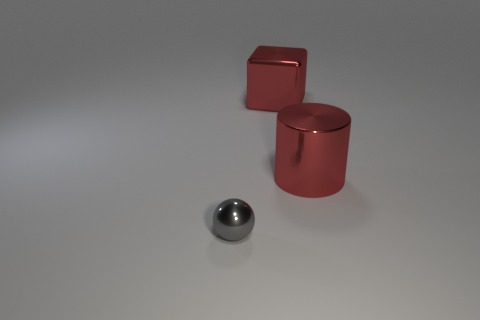Add 1 tiny gray rubber objects. How many objects exist? 4 Subtract all cylinders. How many objects are left? 2 Subtract 1 red cylinders. How many objects are left? 2 Subtract all balls. Subtract all small gray metallic balls. How many objects are left? 1 Add 3 small things. How many small things are left? 4 Add 3 tiny yellow cylinders. How many tiny yellow cylinders exist? 3 